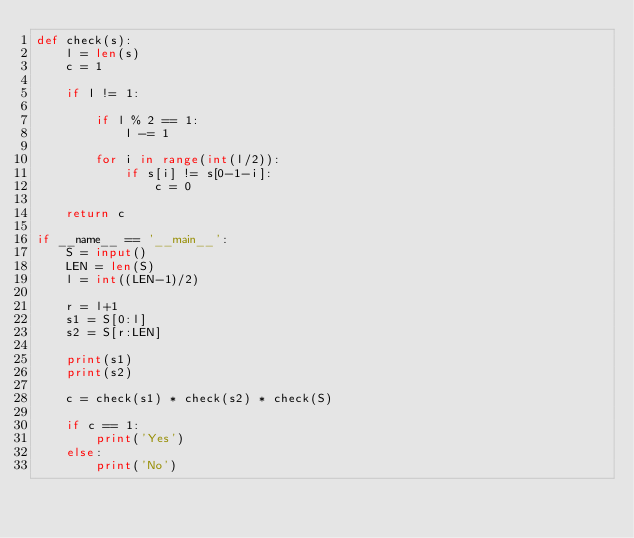<code> <loc_0><loc_0><loc_500><loc_500><_Python_>def check(s):
	l = len(s)
	c = 1

	if l != 1:

		if l % 2 == 1:
			l -= 1

		for i in range(int(l/2)):
			if s[i] != s[0-1-i]:
				c = 0

	return c

if __name__ == '__main__':
	S = input()
	LEN = len(S)
	l = int((LEN-1)/2)

	r = l+1
	s1 = S[0:l]
	s2 = S[r:LEN]

	print(s1)
	print(s2)

	c = check(s1) * check(s2) * check(S)

	if c == 1:
		print('Yes')
	else:
		print('No')</code> 